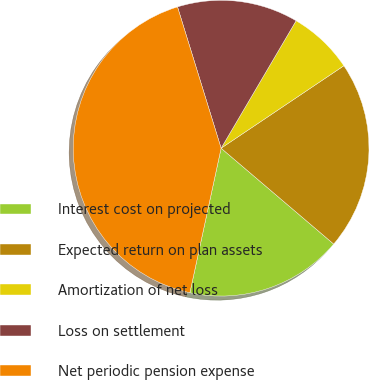<chart> <loc_0><loc_0><loc_500><loc_500><pie_chart><fcel>Interest cost on projected<fcel>Expected return on plan assets<fcel>Amortization of net loss<fcel>Loss on settlement<fcel>Net periodic pension expense<nl><fcel>17.16%<fcel>20.64%<fcel>7.12%<fcel>13.23%<fcel>41.85%<nl></chart> 